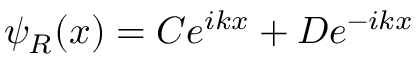<formula> <loc_0><loc_0><loc_500><loc_500>\psi _ { R } ( x ) = C e ^ { i k x } + D e ^ { - i k x }</formula> 